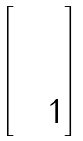<formula> <loc_0><loc_0><loc_500><loc_500>\begin{bmatrix} & & \\ & & \\ & & 1 \end{bmatrix}</formula> 